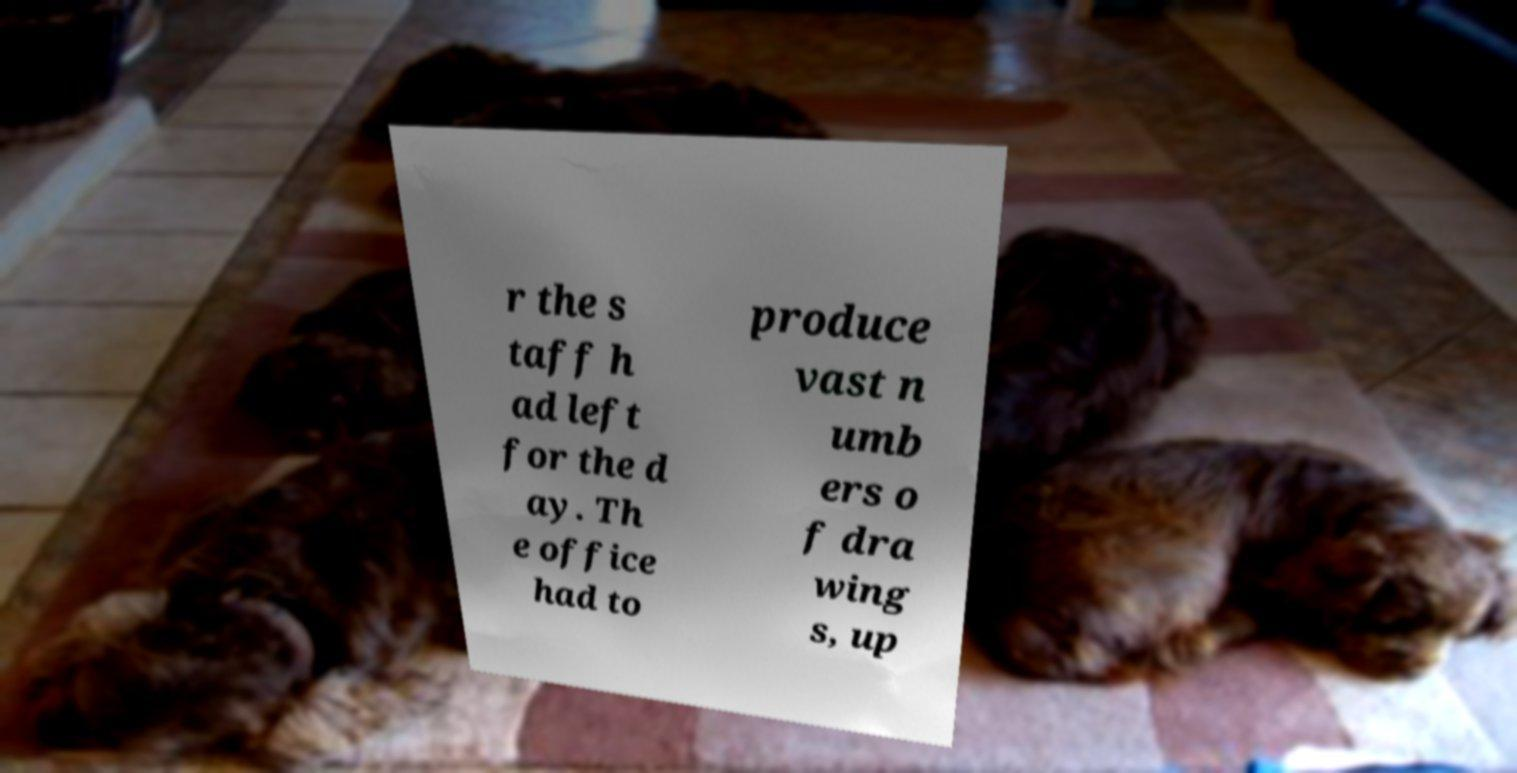I need the written content from this picture converted into text. Can you do that? r the s taff h ad left for the d ay. Th e office had to produce vast n umb ers o f dra wing s, up 